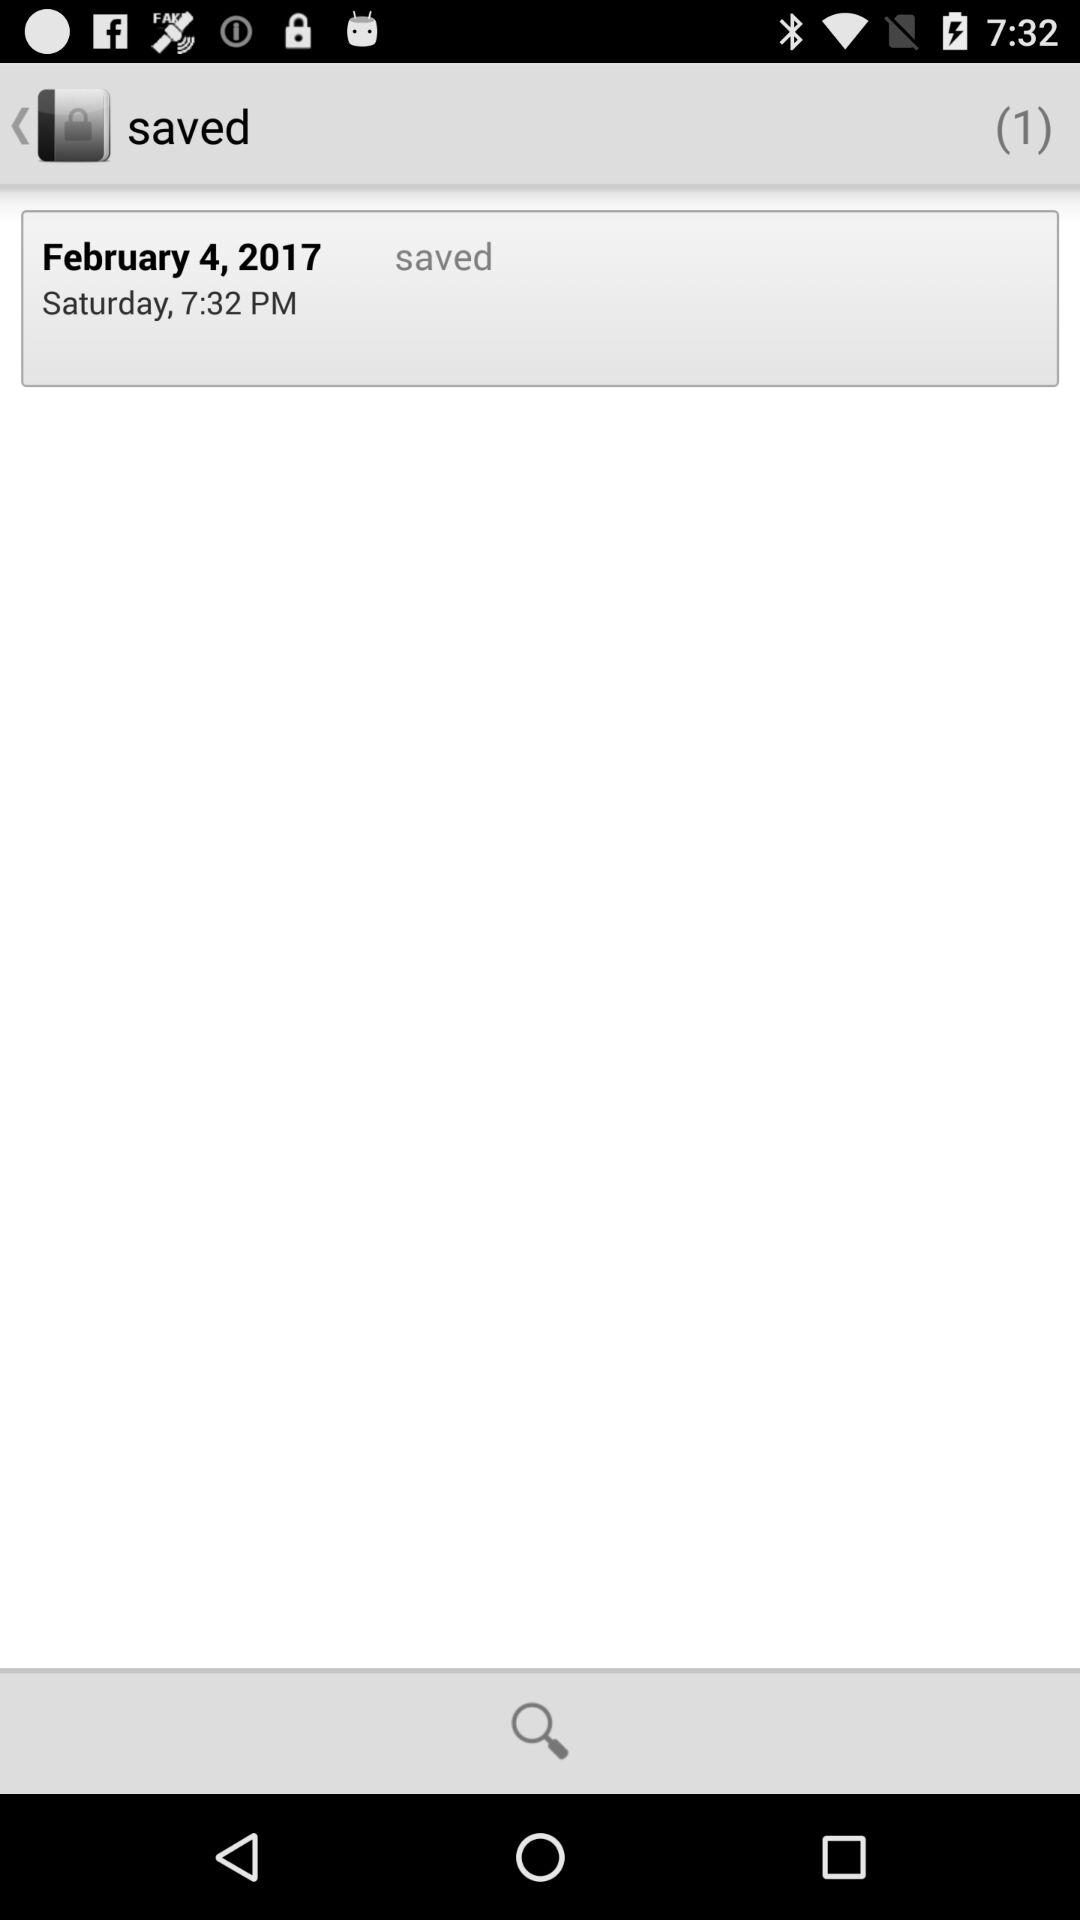How many items are saved? There is 1 item saved. 